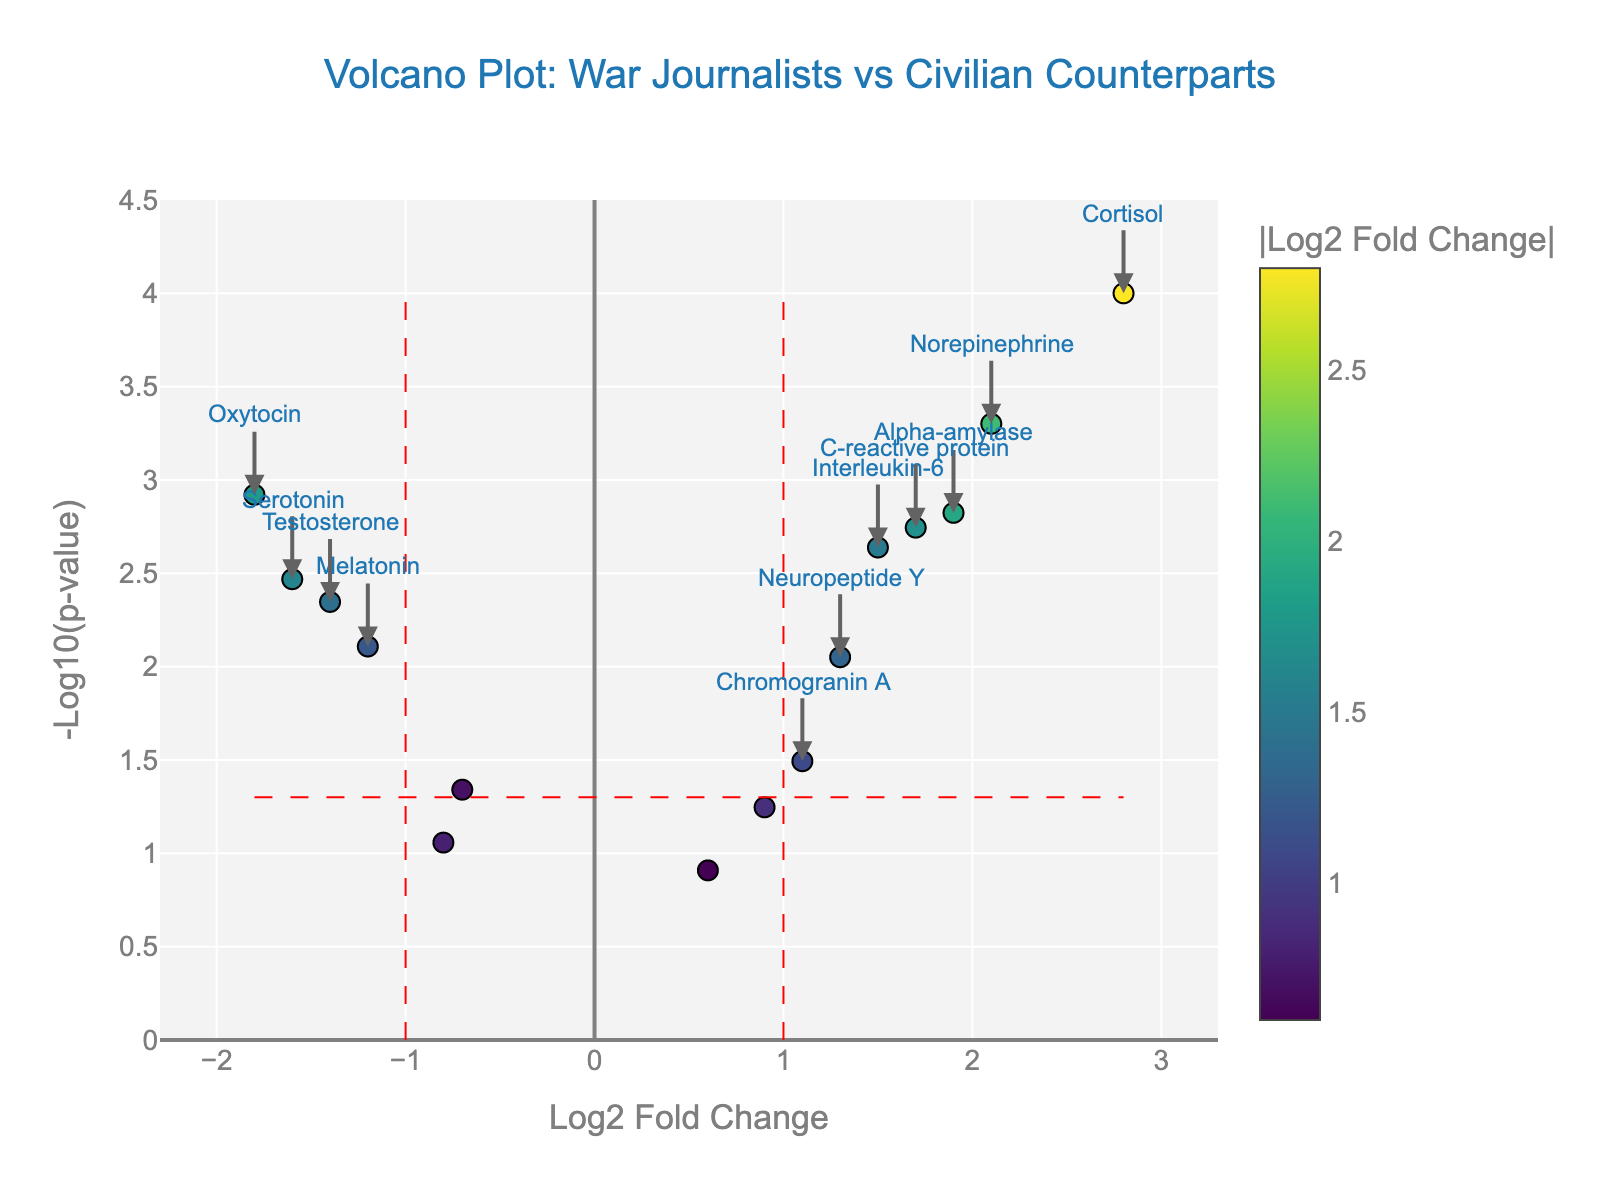what is the title of the figure? The title is displayed at the top of the figure, which typically summarizes what the plot is about. Here, it is "Volcano Plot: War Journalists vs Civilian Counterparts". The title provides a quick overview of the data comparison between war journalists and civilian counterparts.
Answer: Volcano Plot: War Journalists vs Civilian Counterparts how many data points are there in the figure? Each data point in the figure represents a compound. By counting the number of individual markers on the plot, we get the total number of data points. Here, there are 14 compounds listed.
Answer: 14 which compound has the highest log2 fold change? The log2 fold change is on the x-axis, so we look for the compound with the farthest point to the right. Cortisol has the highest log2 fold change of 2.8.
Answer: Cortisol how many compounds have significant p-values (p < 0.05)? On a Volcano Plot, significant p-values (p < 0.05) are reflected by points above the horizontal red significance line. We count the points above this threshold. There are 11 such compounds.
Answer: 11 which compound has the lowest log2 fold change? The compound with the lowest log2 fold change will be the farthest to the left on the x-axis. Oxytocin has the lowest log2 fold change of -1.8.
Answer: Oxytocin how many compounds have both a log2 fold change greater than 1 and p-value less than 0.05? We look for points that are to the right of the vertical red line at log2 fold change = 1 and above the horizontal red line at -log10(p) = 1.3 (since -log10(0.05)=1.3). There are 4 compounds: Cortisol, Alpha-amylase, Norepinephrine, and C-reactive protein.
Answer: 4 which compounds are annotated as significant in the figure? In the Volcano Plot, significant compounds are typically labeled. These annotations are placed near the points of interest. The annotated significant compounds are Cortisol, Alpha-amylase, Norepinephrine, and Oxytocin.
Answer: Cortisol, Alpha-amylase, Norepinephrine, Oxytocin how does the color of data points relate to the figure elements? The color intensity of each data point on the Volcano Plot typically reflects the absolute value of the log2 fold change. Darker or more intense colors indicate higher absolute values.
Answer: Higher absolute log2 fold changes are darker what is the p-value for Testosterone and where is it on the plot? The p-value for Testosterone is 0.0045. To find it on the plot, we calculate -log10(0.0045), which is approximately 2.35, and locate the point at the log2 fold change of -1.4 and -log10(p) of 2.35.
Answer: 2.35 (p-value), (-1.4, 2.35) (coordinates) which compound near the vertical red line has a non-significant p-value? Substance P has a log2 fold change close to but less than 1 and a p-value just above the significance line, making it a non-significant p-value.
Answer: Substance P 